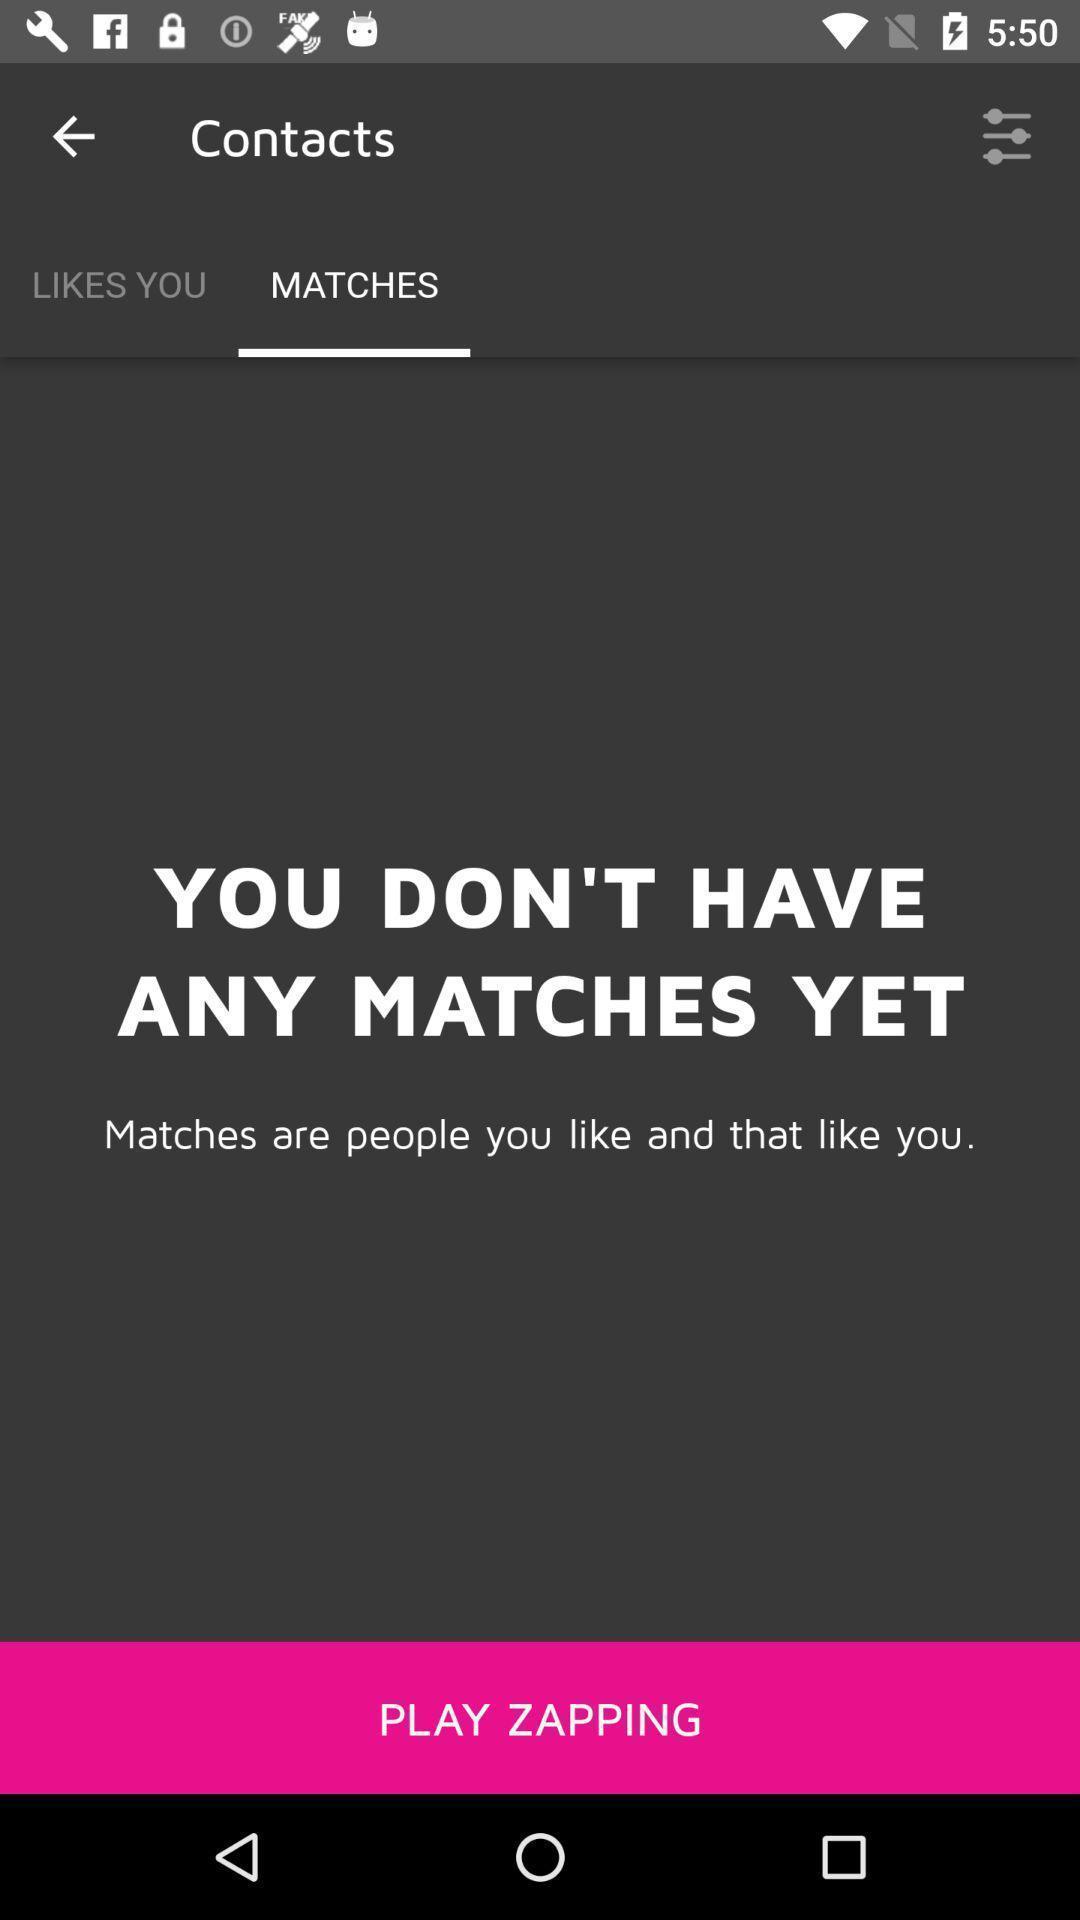Tell me about the visual elements in this screen capture. Page showing you do n't have any matches yet in application. 